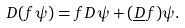Convert formula to latex. <formula><loc_0><loc_0><loc_500><loc_500>D ( f \psi ) = f D \psi + ( { \underline { D } } f ) \psi .</formula> 